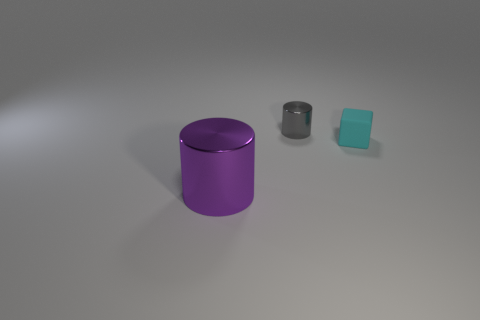What is the color of the large cylinder? The large cylinder in the image has a rich purple hue with a glossy finish that reflects the light, giving it a vibrant appearance. 